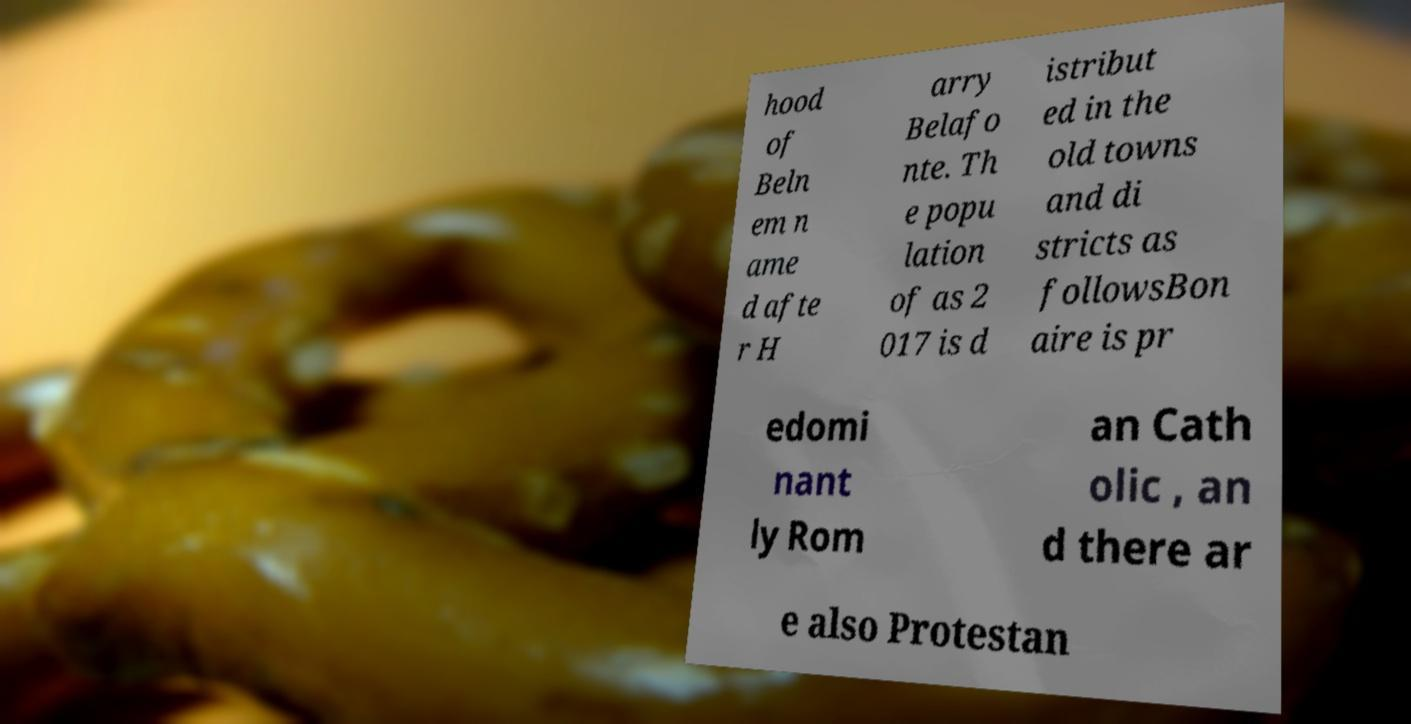There's text embedded in this image that I need extracted. Can you transcribe it verbatim? hood of Beln em n ame d afte r H arry Belafo nte. Th e popu lation of as 2 017 is d istribut ed in the old towns and di stricts as followsBon aire is pr edomi nant ly Rom an Cath olic , an d there ar e also Protestan 